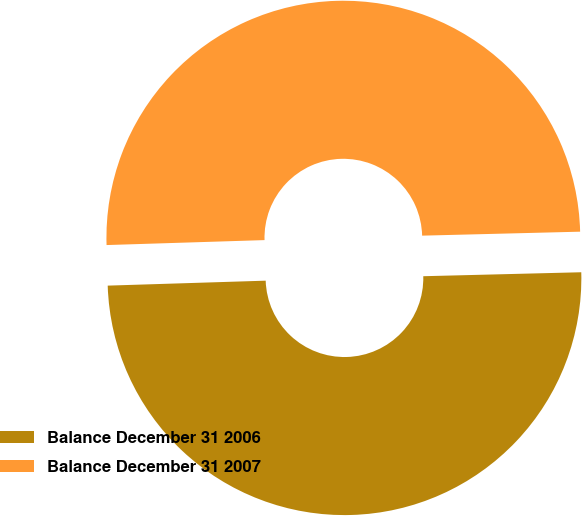Convert chart. <chart><loc_0><loc_0><loc_500><loc_500><pie_chart><fcel>Balance December 31 2006<fcel>Balance December 31 2007<nl><fcel>49.9%<fcel>50.1%<nl></chart> 